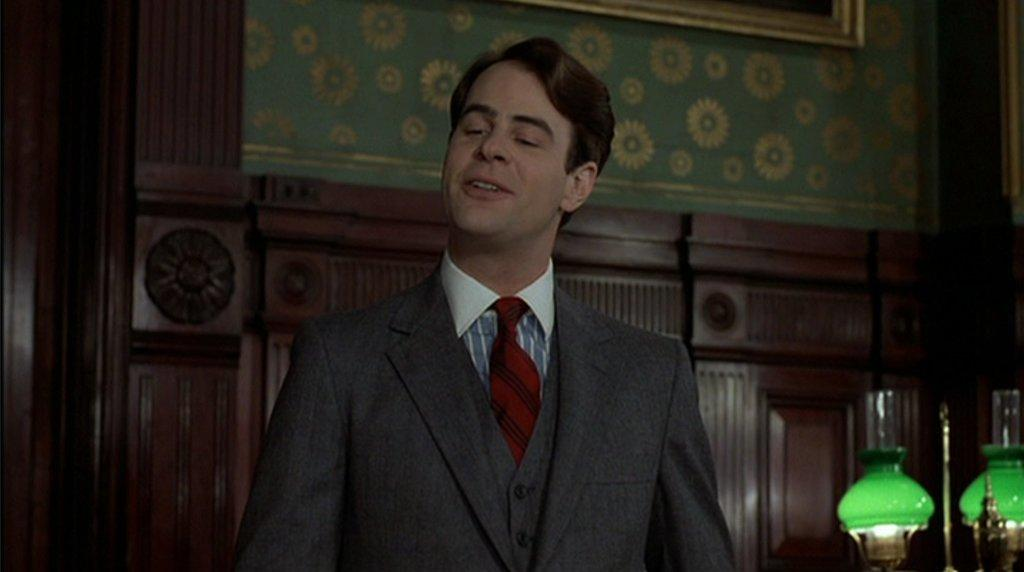What is the main subject of the image? There is a person in the image. What is the person's facial expression? The person is smiling. Can you describe the background of the image? There are objects in the background of the image. What type of rhythm is the person playing on the crate in the image? There is no crate or rhythm present in the image; it only features a person who is smiling. 